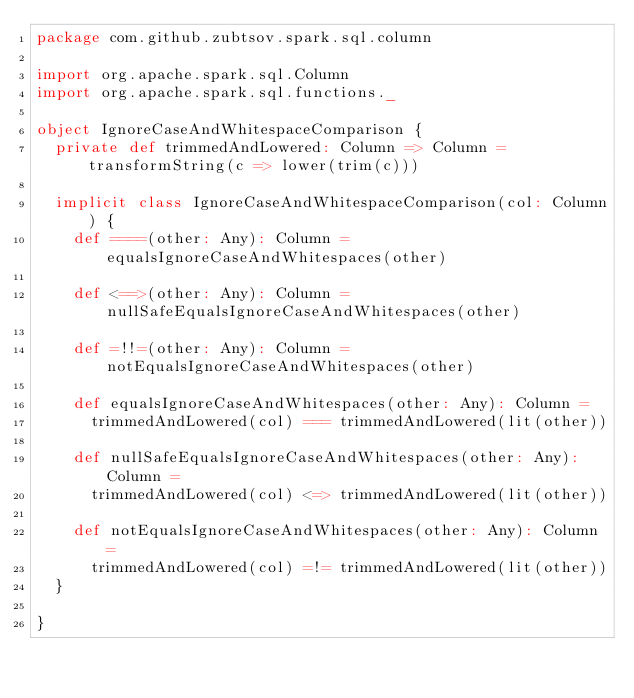Convert code to text. <code><loc_0><loc_0><loc_500><loc_500><_Scala_>package com.github.zubtsov.spark.sql.column

import org.apache.spark.sql.Column
import org.apache.spark.sql.functions._

object IgnoreCaseAndWhitespaceComparison {
  private def trimmedAndLowered: Column => Column = transformString(c => lower(trim(c)))

  implicit class IgnoreCaseAndWhitespaceComparison(col: Column) {
    def ====(other: Any): Column = equalsIgnoreCaseAndWhitespaces(other)

    def <==>(other: Any): Column = nullSafeEqualsIgnoreCaseAndWhitespaces(other)

    def =!!=(other: Any): Column = notEqualsIgnoreCaseAndWhitespaces(other)

    def equalsIgnoreCaseAndWhitespaces(other: Any): Column =
      trimmedAndLowered(col) === trimmedAndLowered(lit(other))

    def nullSafeEqualsIgnoreCaseAndWhitespaces(other: Any): Column =
      trimmedAndLowered(col) <=> trimmedAndLowered(lit(other))

    def notEqualsIgnoreCaseAndWhitespaces(other: Any): Column =
      trimmedAndLowered(col) =!= trimmedAndLowered(lit(other))
  }

}
</code> 